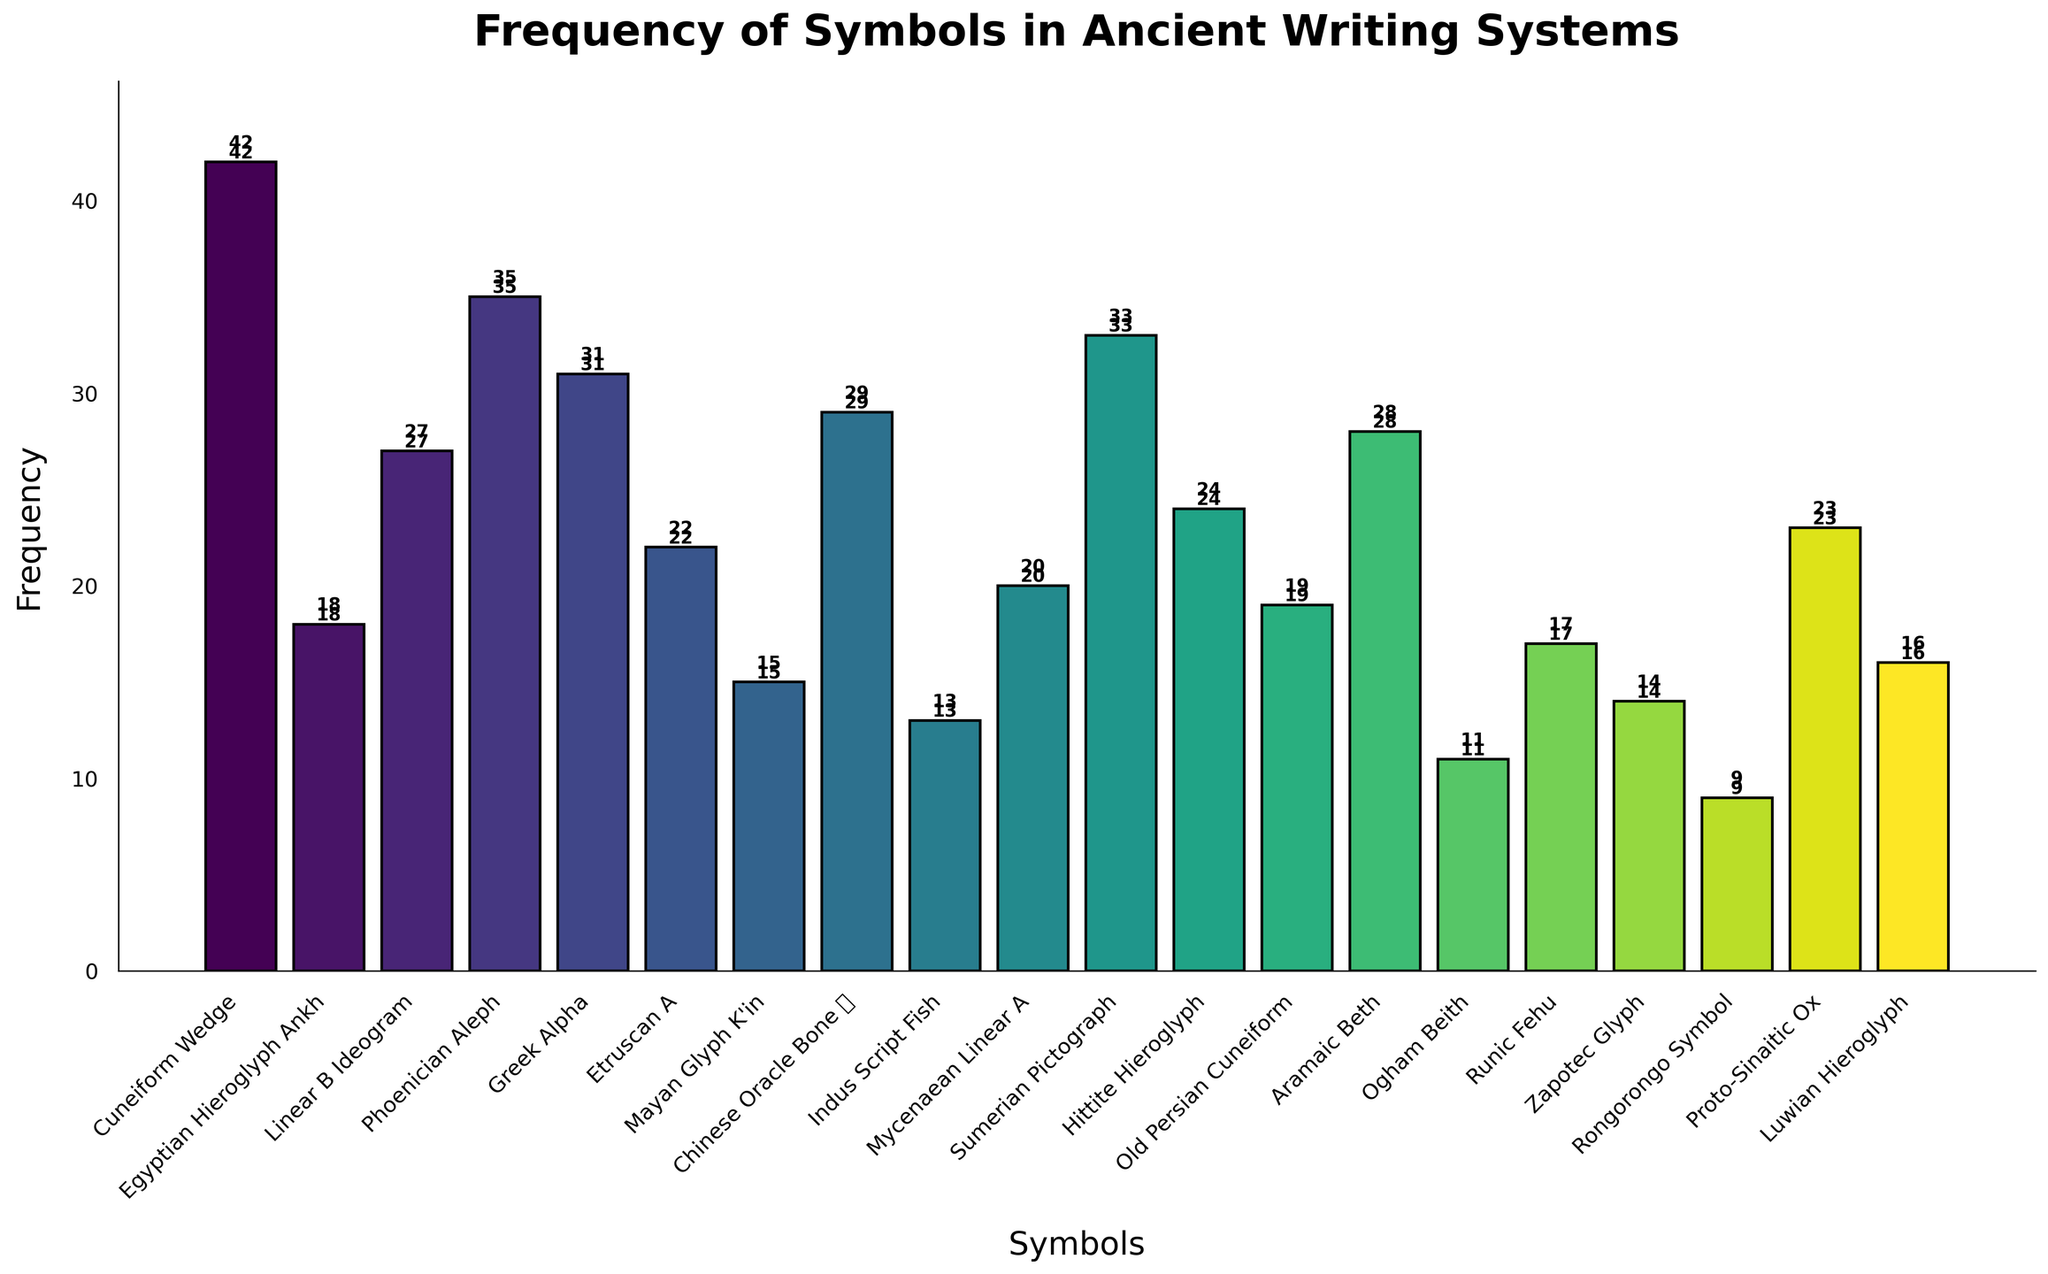Which symbol has the highest frequency? Look at the bar heights and find the tallest one. The tallest bar corresponds to the 'Cuneiform Wedge' symbol with a frequency of 42.
Answer: Cuneiform Wedge Which two symbols have the lowest frequencies? Find the shortest bars. The two shortest bars are 'Rongorongo Symbol' with a frequency of 9 and 'Ogham Beith' with a frequency of 11.
Answer: Rongorongo Symbol, Ogham Beith What is the total frequency of symbols from the Greek, Phoenician, and Egyptian systems? Sum the frequencies of 'Greek Alpha' (31), 'Phoenician Aleph' (35), and 'Egyptian Hieroglyph Ankh' (18). The total is 31 + 35 + 18 = 84.
Answer: 84 Which symbol has a frequency closest to the average frequency of all symbols? Calculate the average frequency first. Sum all frequencies and divide by the number of symbols: (42 + 18 + 27 + 35 + 31 + 22 + 15 + 29 + 13 + 20 + 33 + 24 + 19 + 28 + 11 + 17 + 14 + 9 + 23 + 16) / 20 = 24.25. The closest frequency to 24.25 is 'Hittite Hieroglyph' with a frequency of 24.
Answer: Hittite Hieroglyph What is the difference in frequency between the highest and the lowest symbol? Subtract the lowest frequency (9 for Rongorongo Symbol) from the highest frequency (42 for Cuneiform Wedge): 42 - 9 = 33.
Answer: 33 Arrange the symbols in ascending order of frequency. List the symbols in order from the lowest to the highest frequency: Rongorongo Symbol (9), Ogham Beith (11), Indus Script Fish (13), Zapotec Glyph (14), Mayan Glyph K'in (15), Luwian Hieroglyph (16), Runic Fehu (17), Egyptian Hieroglyph Ankh (18), Old Persian Cuneiform (19), Mycenaean Linear A (20), Etruscan A (22), Proto-Sinaitic Ox (23), Hittite Hieroglyph (24), Linear B Ideogram (27), Aramaic Beth (28), Chinese Oracle Bone 日 (29), Greek Alpha (31), Sumerian Pictograph (33), Phoenician Aleph (35), Cuneiform Wedge (42).
Answer: Rongorongo Symbol, Ogham Beith, Indus Script Fish, Zapotec Glyph, Mayan Glyph K'in, Luwian Hieroglyph, Runic Fehu, Egyptian Hieroglyph Ankh, Old Persian Cuneiform, Mycenaean Linear A, Etruscan A, Proto-Sinaitic Ox, Hittite Hieroglyph, Linear B Ideogram, Aramaic Beth, Chinese Oracle Bone 日, Greek Alpha, Sumerian Pictograph, Phoenician Aleph, Cuneiform Wedge Which has a higher frequency, 'Chinese Oracle Bone 日' or 'Aramaic Beth'? Compare the heights of the bars for 'Chinese Oracle Bone 日' (29) and 'Aramaic Beth' (28). 'Chinese Oracle Bone 日' has a higher frequency.
Answer: Chinese Oracle Bone 日 What is the frequency range of the symbols? Subtract the lowest frequency (9 for Rongorongo Symbol) from the highest frequency (42 for Cuneiform Wedge): 42 - 9 = 33.
Answer: 33 How many symbols have a frequency greater than 25? Count the bars with heights greater than 25: 'Cuneiform Wedge' (42), 'Phoenician Aleph' (35), 'Greek Alpha' (31), 'Aramaic Beth' (28), 'Chinese Oracle Bone 日' (29), 'Sumerian Pictograph' (33), and 'Linear B Ideogram' (27). There are 7 symbols.
Answer: 7 What is the median frequency of the symbols? Arrange the frequencies in ascending order: 9, 11, 13, 14, 15, 16, 17, 18, 19, 20, 22, 23, 24, 27, 28, 29, 31, 33, 35, 42. The middle values are 20 and 22. The median is the average of these two: (20 + 22) / 2 = 21.
Answer: 21 